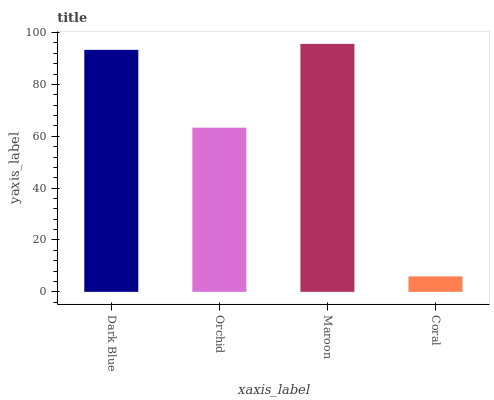Is Coral the minimum?
Answer yes or no. Yes. Is Maroon the maximum?
Answer yes or no. Yes. Is Orchid the minimum?
Answer yes or no. No. Is Orchid the maximum?
Answer yes or no. No. Is Dark Blue greater than Orchid?
Answer yes or no. Yes. Is Orchid less than Dark Blue?
Answer yes or no. Yes. Is Orchid greater than Dark Blue?
Answer yes or no. No. Is Dark Blue less than Orchid?
Answer yes or no. No. Is Dark Blue the high median?
Answer yes or no. Yes. Is Orchid the low median?
Answer yes or no. Yes. Is Orchid the high median?
Answer yes or no. No. Is Coral the low median?
Answer yes or no. No. 